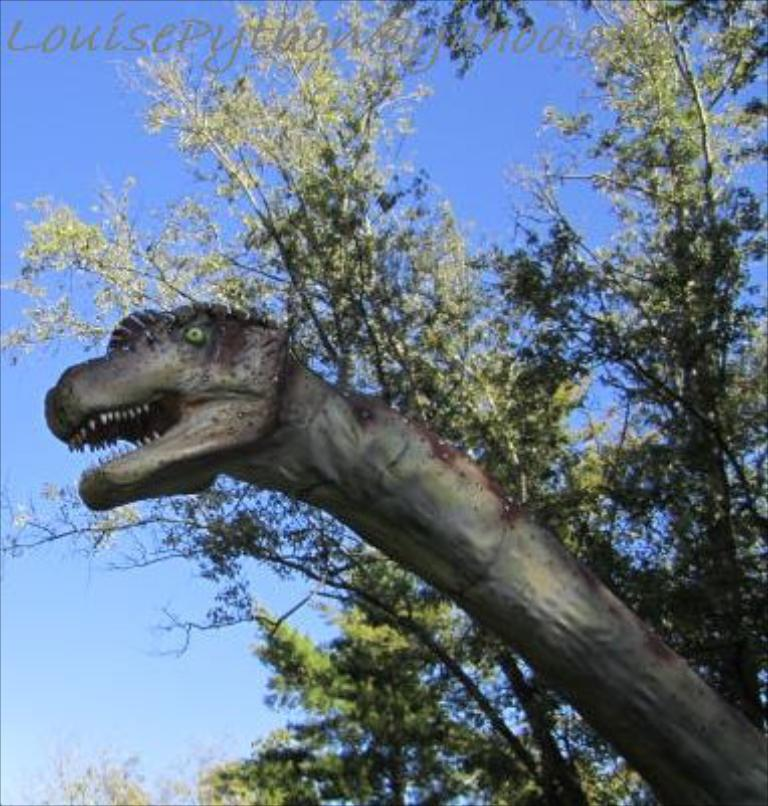What is the main subject of the image? There is a sculpture of a dinosaur in the image. What can be seen in the background of the image? There are trees and the sky visible in the background of the image. What type of hat is the dinosaur wearing in the image? The dinosaur sculpture in the image is not wearing a hat, as it is a sculpture and not a living creature. 